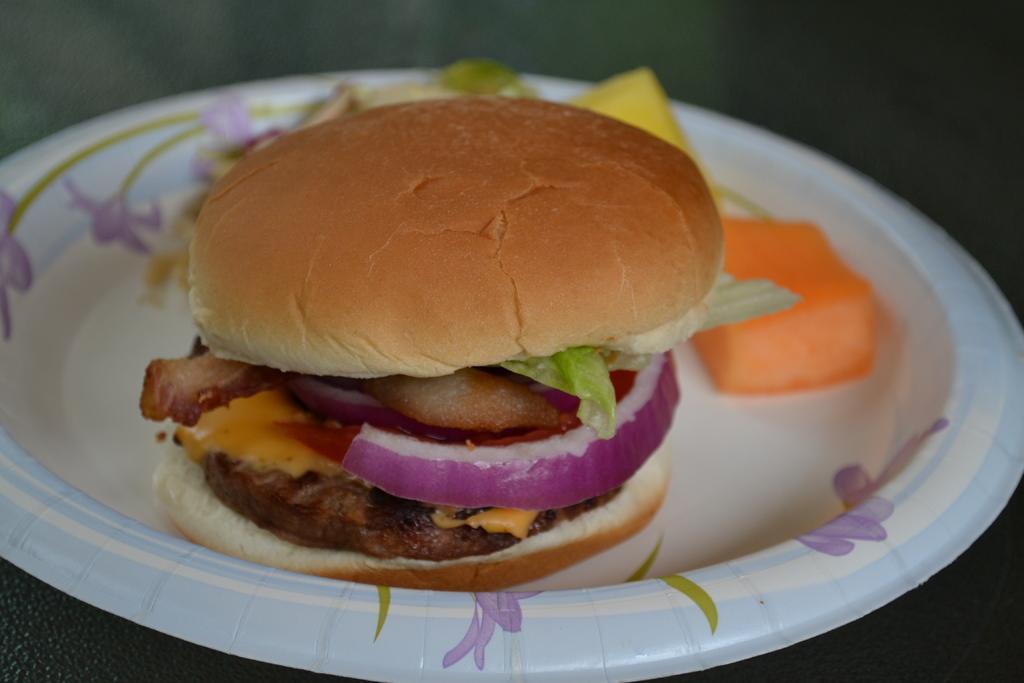Describe this image in one or two sentences. In this picture I can see a burger and some food in the plate. I can see a dark background. 